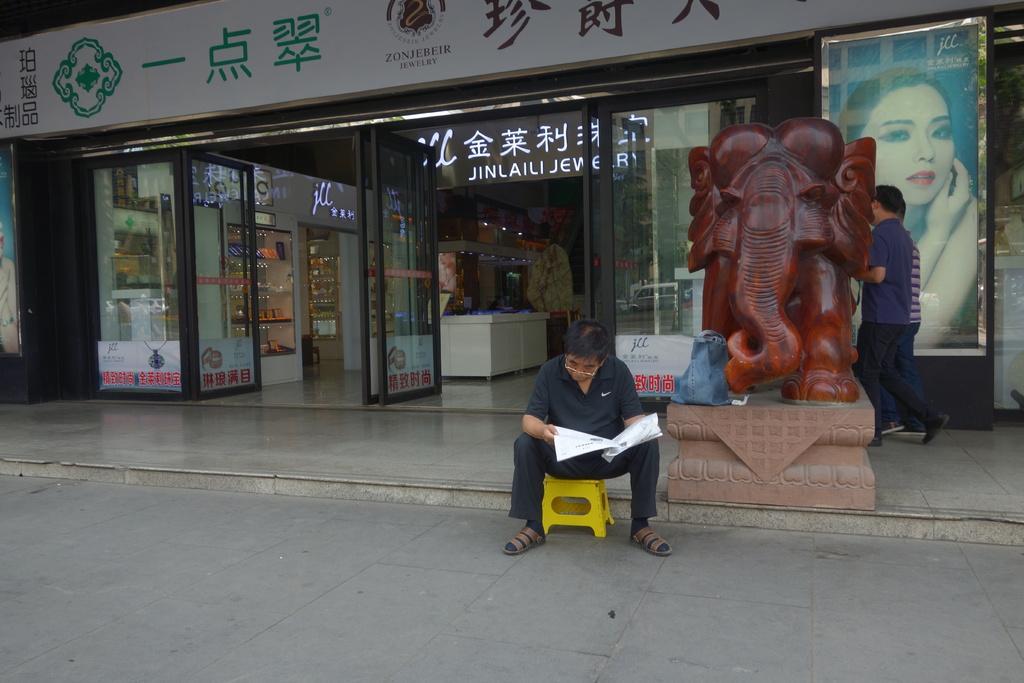How would you summarize this image in a sentence or two? In this image there is a man sitting on the stool, he is reading a newspaper, there are two men walking, there is a sculptor of an elephant, there is a shop, there is a photo frame, there is a woman on the photo frame, there is a board towards the top of the image, there is text on the board, there are doors, there are shelves, there are objects on the shelves, at the background of the image there is a ground, there is a glass wall. 